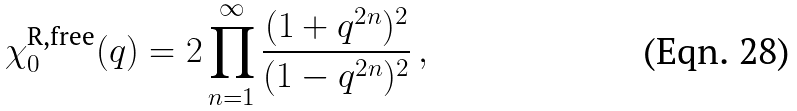<formula> <loc_0><loc_0><loc_500><loc_500>\chi _ { 0 } ^ { \text {R,free} } ( q ) = 2 \prod _ { n = 1 } ^ { \infty } \frac { ( 1 + q ^ { 2 n } ) ^ { 2 } } { ( 1 - q ^ { 2 n } ) ^ { 2 } } \, ,</formula> 